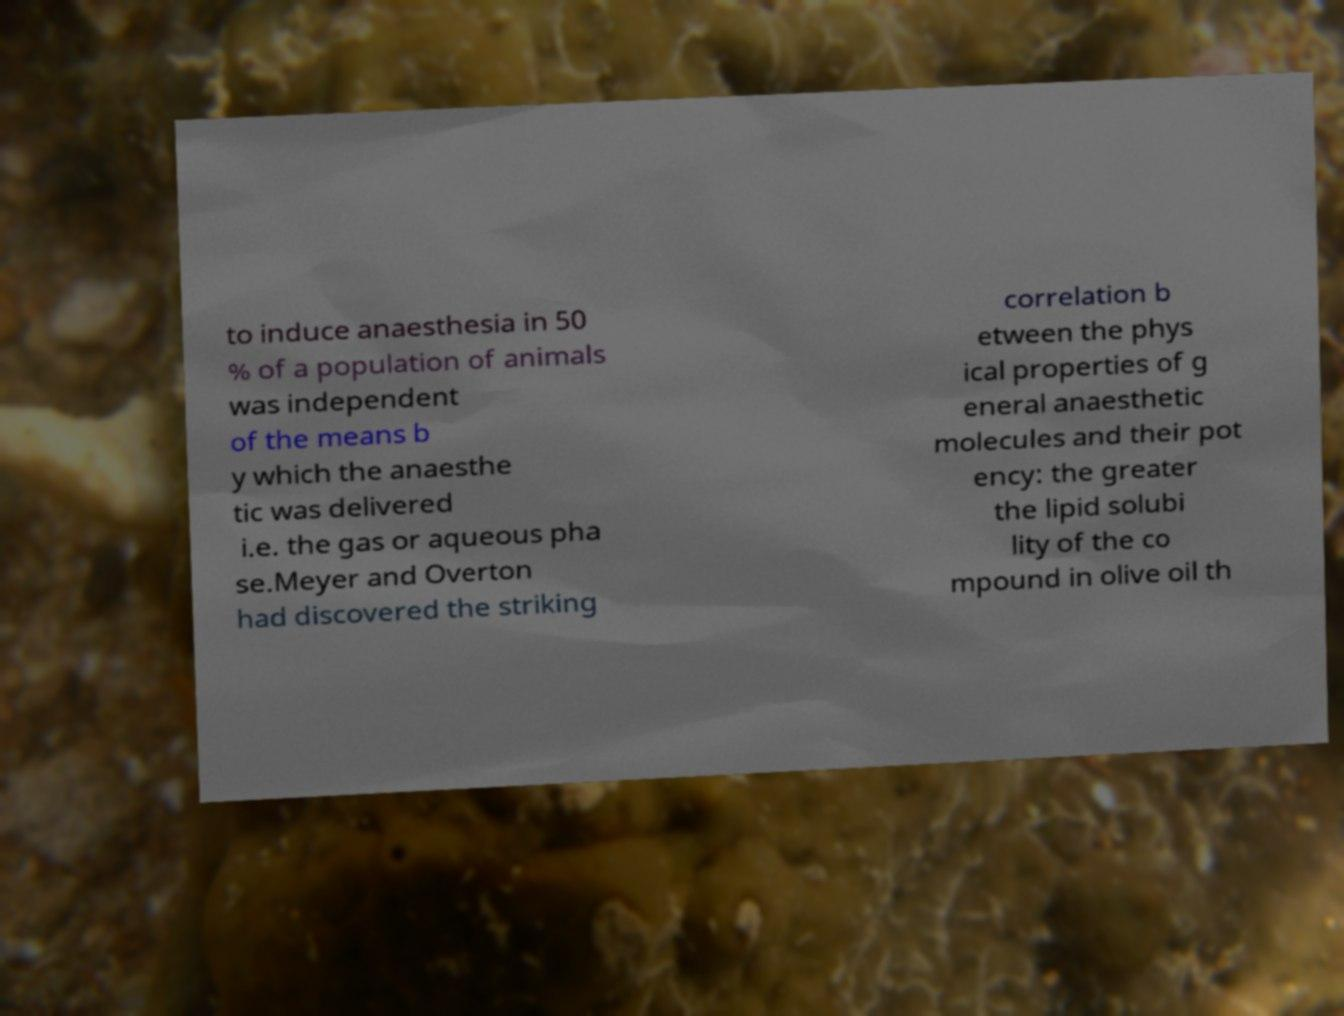Please read and relay the text visible in this image. What does it say? to induce anaesthesia in 50 % of a population of animals was independent of the means b y which the anaesthe tic was delivered i.e. the gas or aqueous pha se.Meyer and Overton had discovered the striking correlation b etween the phys ical properties of g eneral anaesthetic molecules and their pot ency: the greater the lipid solubi lity of the co mpound in olive oil th 